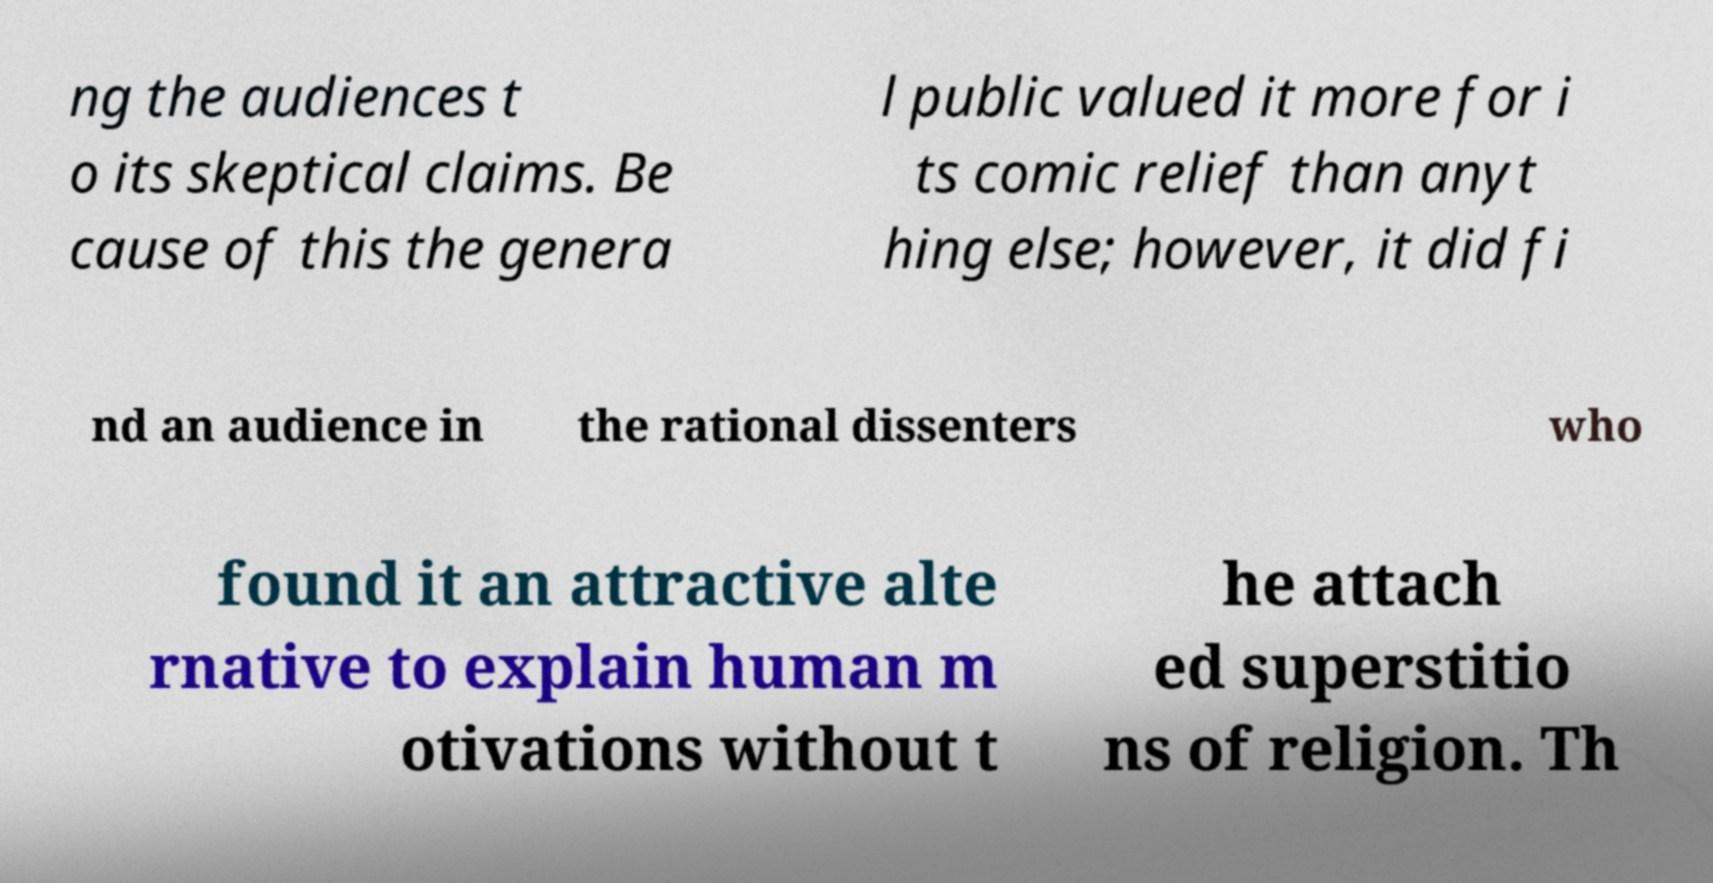Could you extract and type out the text from this image? ng the audiences t o its skeptical claims. Be cause of this the genera l public valued it more for i ts comic relief than anyt hing else; however, it did fi nd an audience in the rational dissenters who found it an attractive alte rnative to explain human m otivations without t he attach ed superstitio ns of religion. Th 